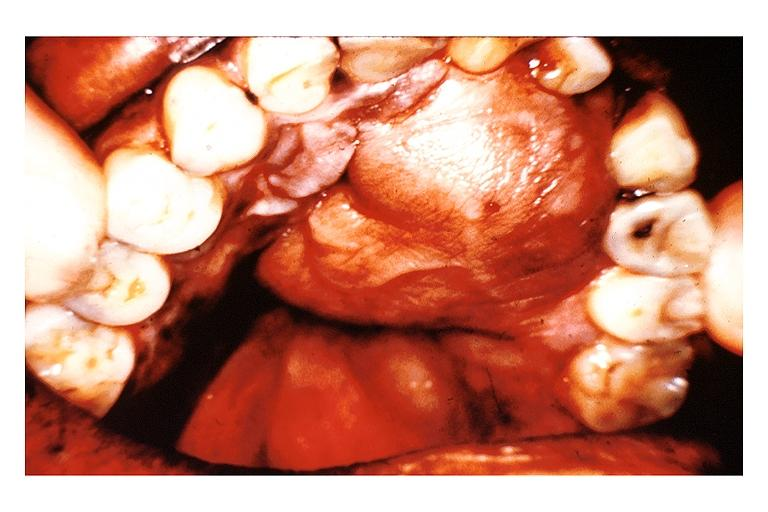does this image show neurofibroma?
Answer the question using a single word or phrase. Yes 